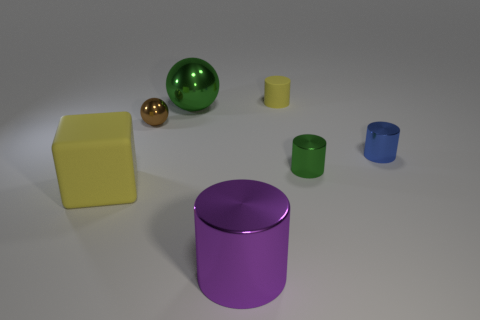How many other things are the same shape as the brown shiny object?
Your answer should be very brief. 1. Are the green thing to the left of the big purple shiny thing and the tiny blue thing made of the same material?
Offer a terse response. Yes. What number of things are brown objects or big purple rubber blocks?
Make the answer very short. 1. The green thing that is the same shape as the brown shiny thing is what size?
Provide a succinct answer. Large. What size is the matte cylinder?
Give a very brief answer. Small. Is the number of blue shiny cylinders that are behind the yellow cylinder greater than the number of tiny objects?
Your answer should be very brief. No. Is the color of the large metallic object that is behind the big yellow matte object the same as the tiny shiny object to the left of the large purple object?
Make the answer very short. No. What material is the sphere to the right of the small thing to the left of the green thing that is behind the small green shiny cylinder made of?
Your answer should be very brief. Metal. Is the number of tiny green cylinders greater than the number of objects?
Keep it short and to the point. No. Is there anything else of the same color as the large metallic ball?
Ensure brevity in your answer.  Yes. 